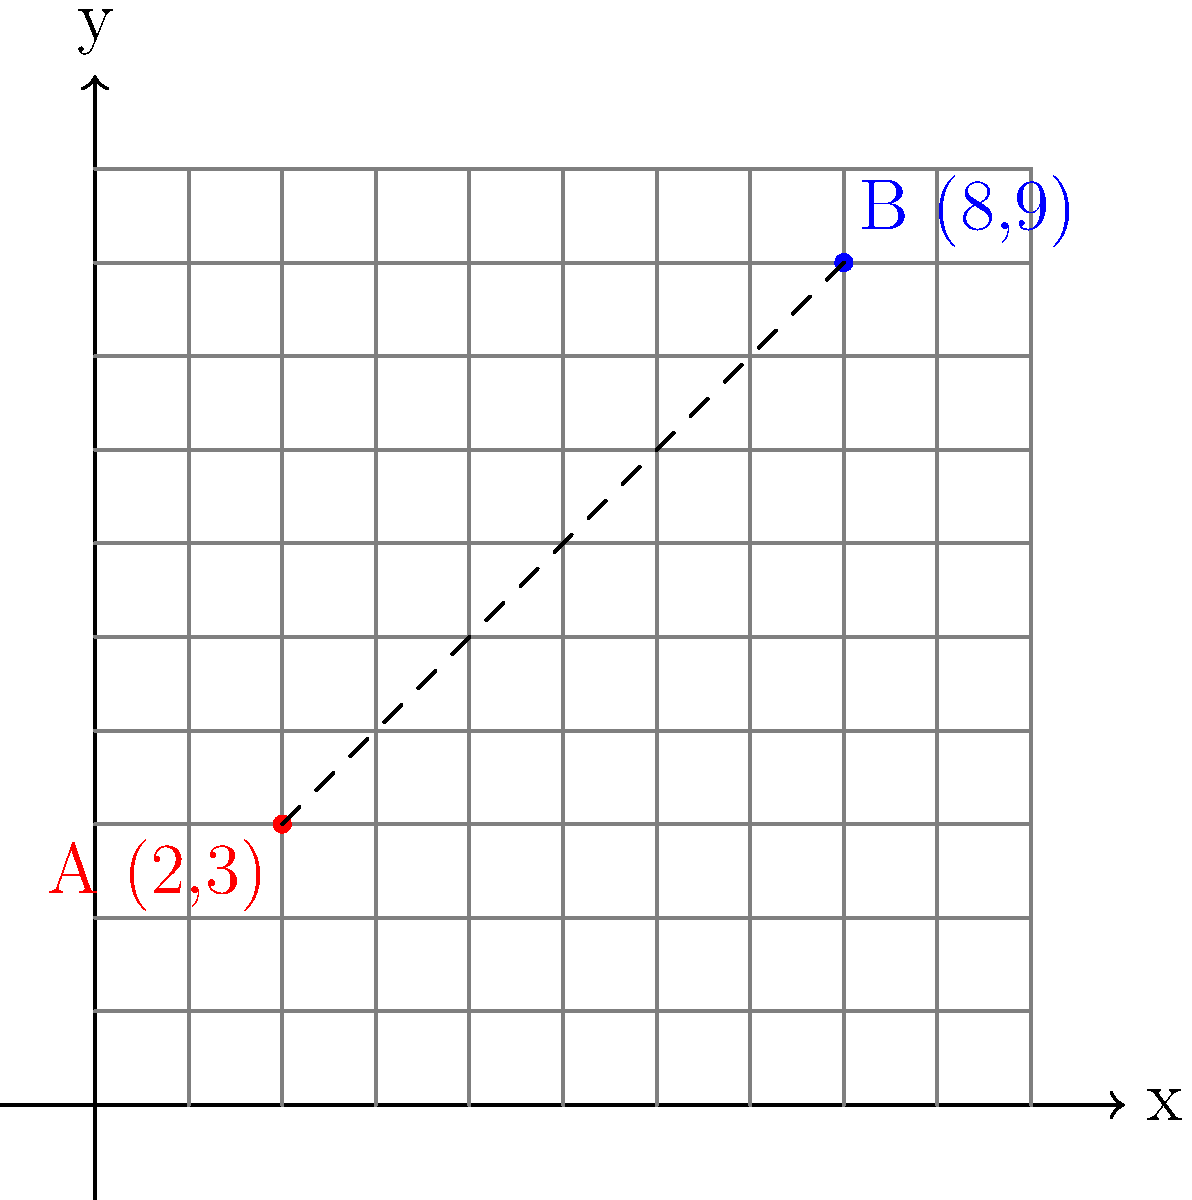As a real estate agent, you're analyzing a neighborhood map where properties are represented by coordinate points. Property A is located at (2,3) and Property B is at (8,9). Calculate the straight-line distance between these two properties to help a client understand their proximity. Round your answer to two decimal places. To find the distance between two points on a coordinate plane, we can use the distance formula, which is derived from the Pythagorean theorem:

Distance = $\sqrt{(x_2-x_1)^2 + (y_2-y_1)^2}$

Where $(x_1,y_1)$ are the coordinates of the first point and $(x_2,y_2)$ are the coordinates of the second point.

Let's solve this step-by-step:

1) Identify the coordinates:
   Property A: $(x_1,y_1) = (2,3)$
   Property B: $(x_2,y_2) = (8,9)$

2) Plug these into the distance formula:
   Distance = $\sqrt{(8-2)^2 + (9-3)^2}$

3) Simplify inside the parentheses:
   Distance = $\sqrt{6^2 + 6^2}$

4) Calculate the squares:
   Distance = $\sqrt{36 + 36}$

5) Add inside the square root:
   Distance = $\sqrt{72}$

6) Simplify the square root:
   Distance = $6\sqrt{2}$

7) Use a calculator to get the decimal approximation:
   Distance ≈ 8.4853...

8) Round to two decimal places:
   Distance ≈ 8.49

Therefore, the straight-line distance between Property A and Property B is approximately 8.49 units on the map.
Answer: 8.49 units 